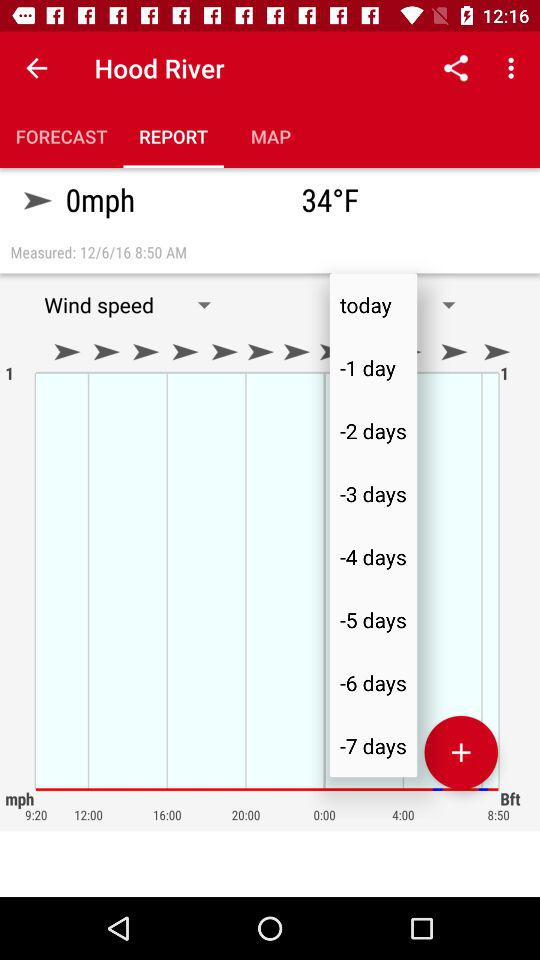Which chart is being shown right now?
When the provided information is insufficient, respond with <no answer>. <no answer> 